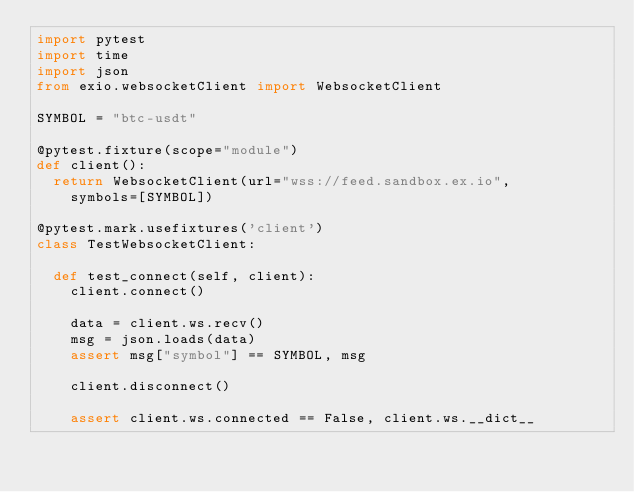Convert code to text. <code><loc_0><loc_0><loc_500><loc_500><_Python_>import pytest
import time
import json
from exio.websocketClient import WebsocketClient

SYMBOL = "btc-usdt"

@pytest.fixture(scope="module")
def client():
  return WebsocketClient(url="wss://feed.sandbox.ex.io", 
    symbols=[SYMBOL])

@pytest.mark.usefixtures('client')
class TestWebsocketClient:

  def test_connect(self, client):
    client.connect()

    data = client.ws.recv()
    msg = json.loads(data)
    assert msg["symbol"] == SYMBOL, msg

    client.disconnect()

    assert client.ws.connected == False, client.ws.__dict__
</code> 